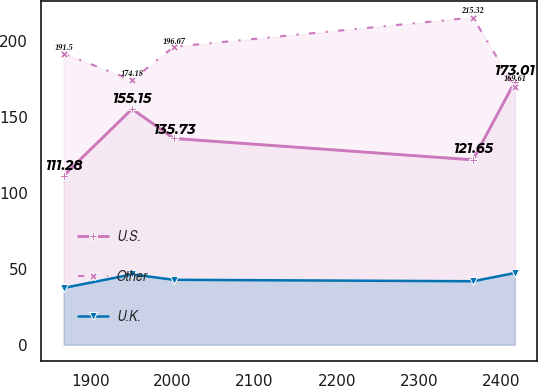Convert chart. <chart><loc_0><loc_0><loc_500><loc_500><line_chart><ecel><fcel>U.S.<fcel>Other<fcel>U.K.<nl><fcel>1867.71<fcel>111.28<fcel>191.5<fcel>37.38<nl><fcel>1950.93<fcel>155.15<fcel>174.18<fcel>46.29<nl><fcel>2001.79<fcel>135.73<fcel>196.07<fcel>42.73<nl><fcel>2365.73<fcel>121.65<fcel>215.32<fcel>41.78<nl><fcel>2416.59<fcel>173.01<fcel>169.61<fcel>47.19<nl></chart> 